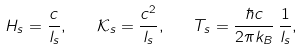Convert formula to latex. <formula><loc_0><loc_0><loc_500><loc_500>H _ { s } = \frac { c } { l _ { s } } , \quad \mathcal { K } _ { s } = \frac { c ^ { 2 } } { l _ { s } } , \quad T _ { s } = \frac { \hbar { c } } { 2 \pi k _ { B } } \, \frac { 1 } { l _ { s } } ,</formula> 